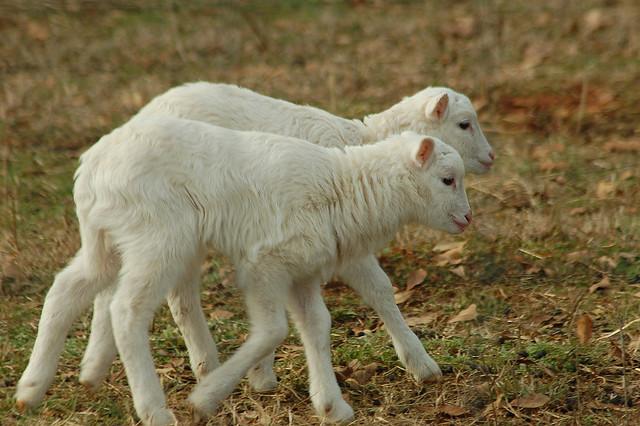How many legs are visible?
Keep it brief. 8. Are they siblings?
Quick response, please. Yes. Are the walking at the same speed?
Answer briefly. Yes. 